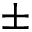Convert formula to latex. <formula><loc_0><loc_0><loc_500><loc_500>\pm</formula> 